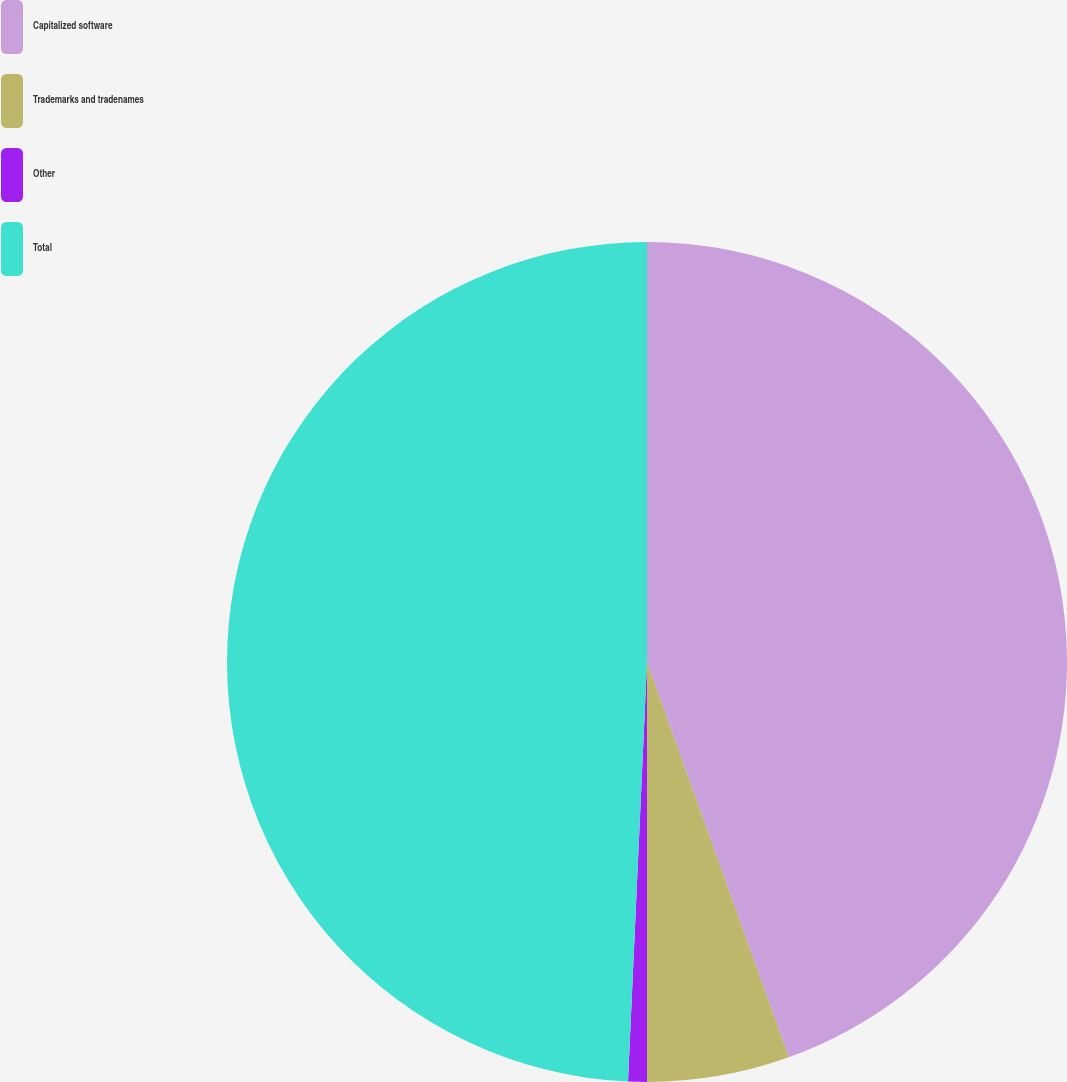<chart> <loc_0><loc_0><loc_500><loc_500><pie_chart><fcel>Capitalized software<fcel>Trademarks and tradenames<fcel>Other<fcel>Total<nl><fcel>44.52%<fcel>5.48%<fcel>0.72%<fcel>49.28%<nl></chart> 